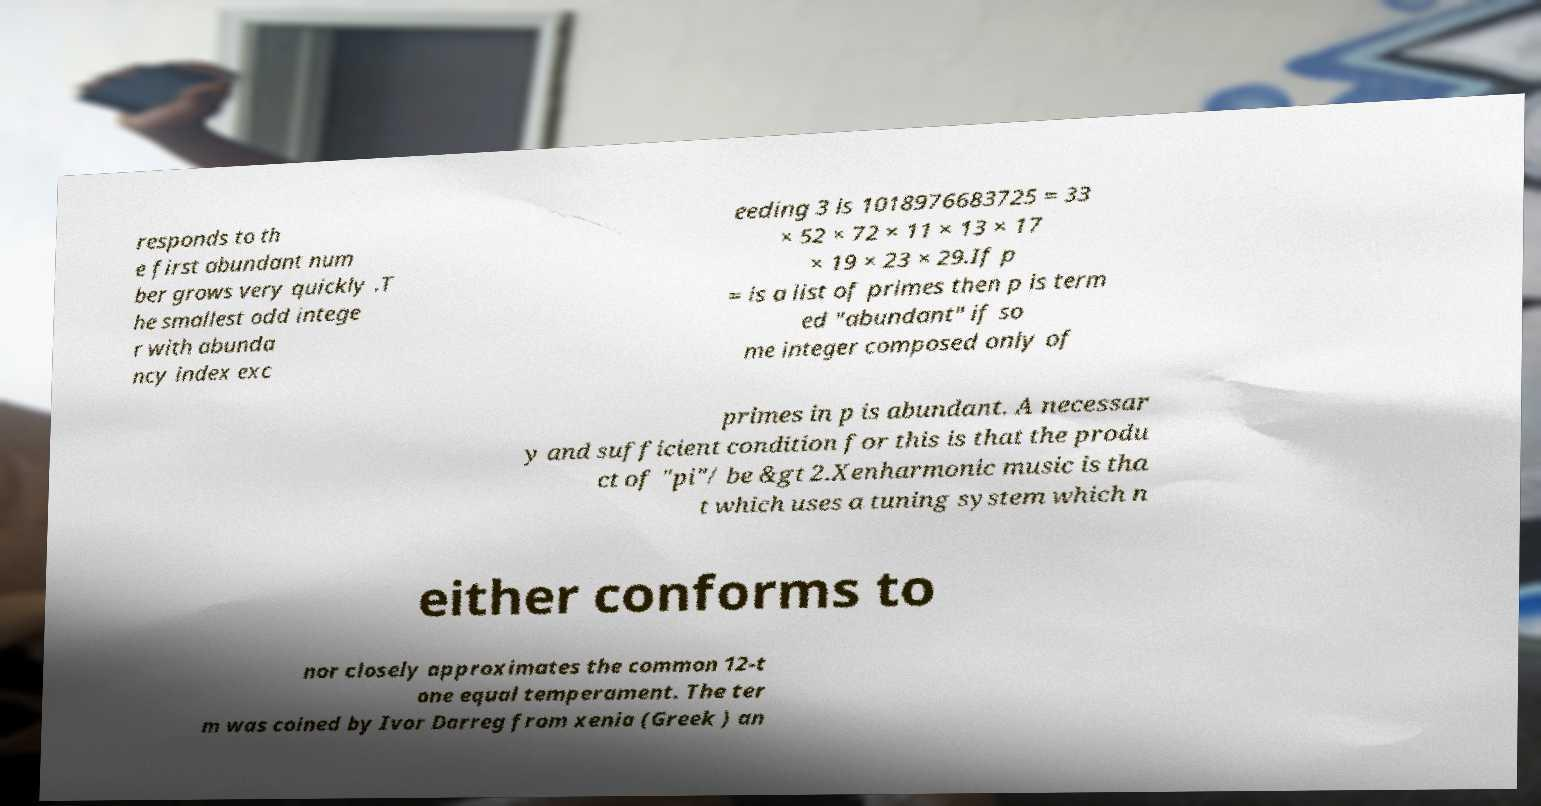There's text embedded in this image that I need extracted. Can you transcribe it verbatim? responds to th e first abundant num ber grows very quickly .T he smallest odd intege r with abunda ncy index exc eeding 3 is 1018976683725 = 33 × 52 × 72 × 11 × 13 × 17 × 19 × 23 × 29.If p = is a list of primes then p is term ed "abundant" if so me integer composed only of primes in p is abundant. A necessar y and sufficient condition for this is that the produ ct of "pi"/ be &gt 2.Xenharmonic music is tha t which uses a tuning system which n either conforms to nor closely approximates the common 12-t one equal temperament. The ter m was coined by Ivor Darreg from xenia (Greek ) an 